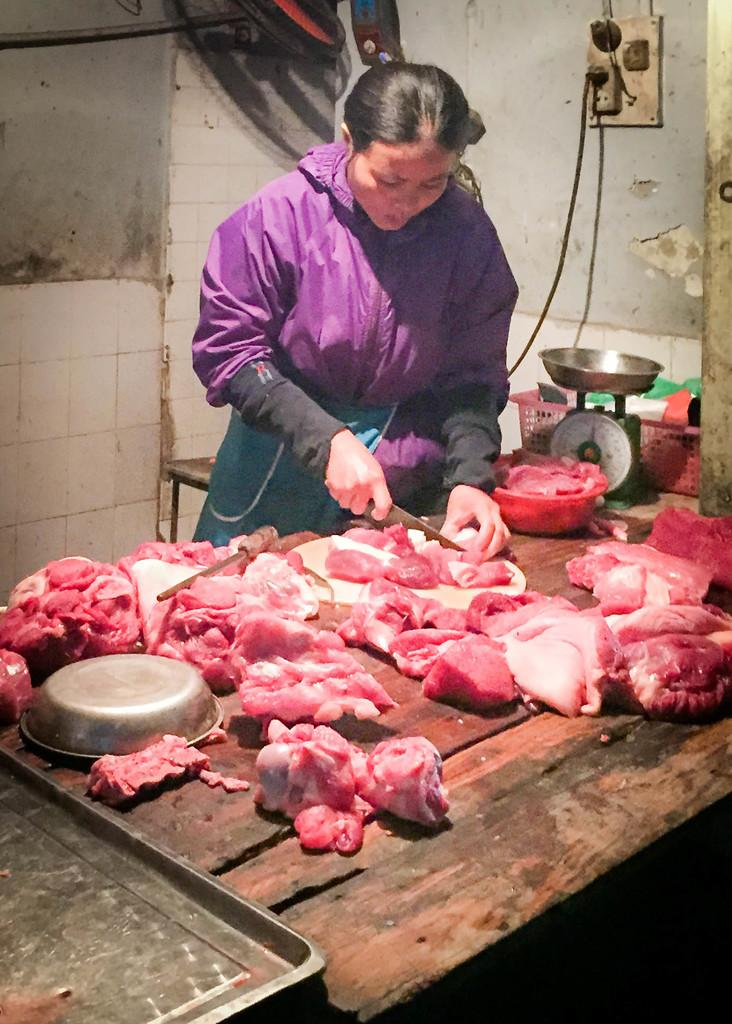Who is the main subject in the image? There is a lady in the image. What is the lady doing in the image? The lady is chopping meat on a table. What other object is present near the lady? There is a weighing machine beside the lady. What can be seen in the background of the image? There is a socket attached to the wall in the background of the image. How many cars are parked in front of the lady in the image? There are no cars visible in the image; it only shows the lady, the table, the weighing machine, and the background with the socket. 